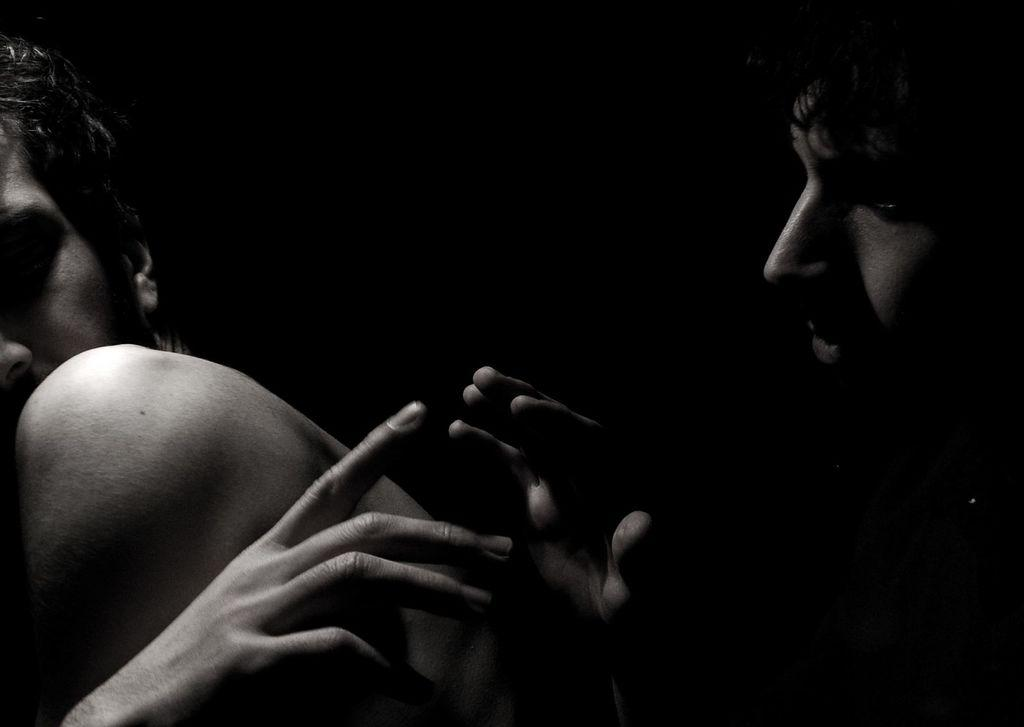What is the color scheme of the image? The image is black and white. How many people are present in the image? There are two men in the image. What type of jam is being spread by one of the men in the image? There is no jam or any indication of food in the image; it is a black and white image of two men. 